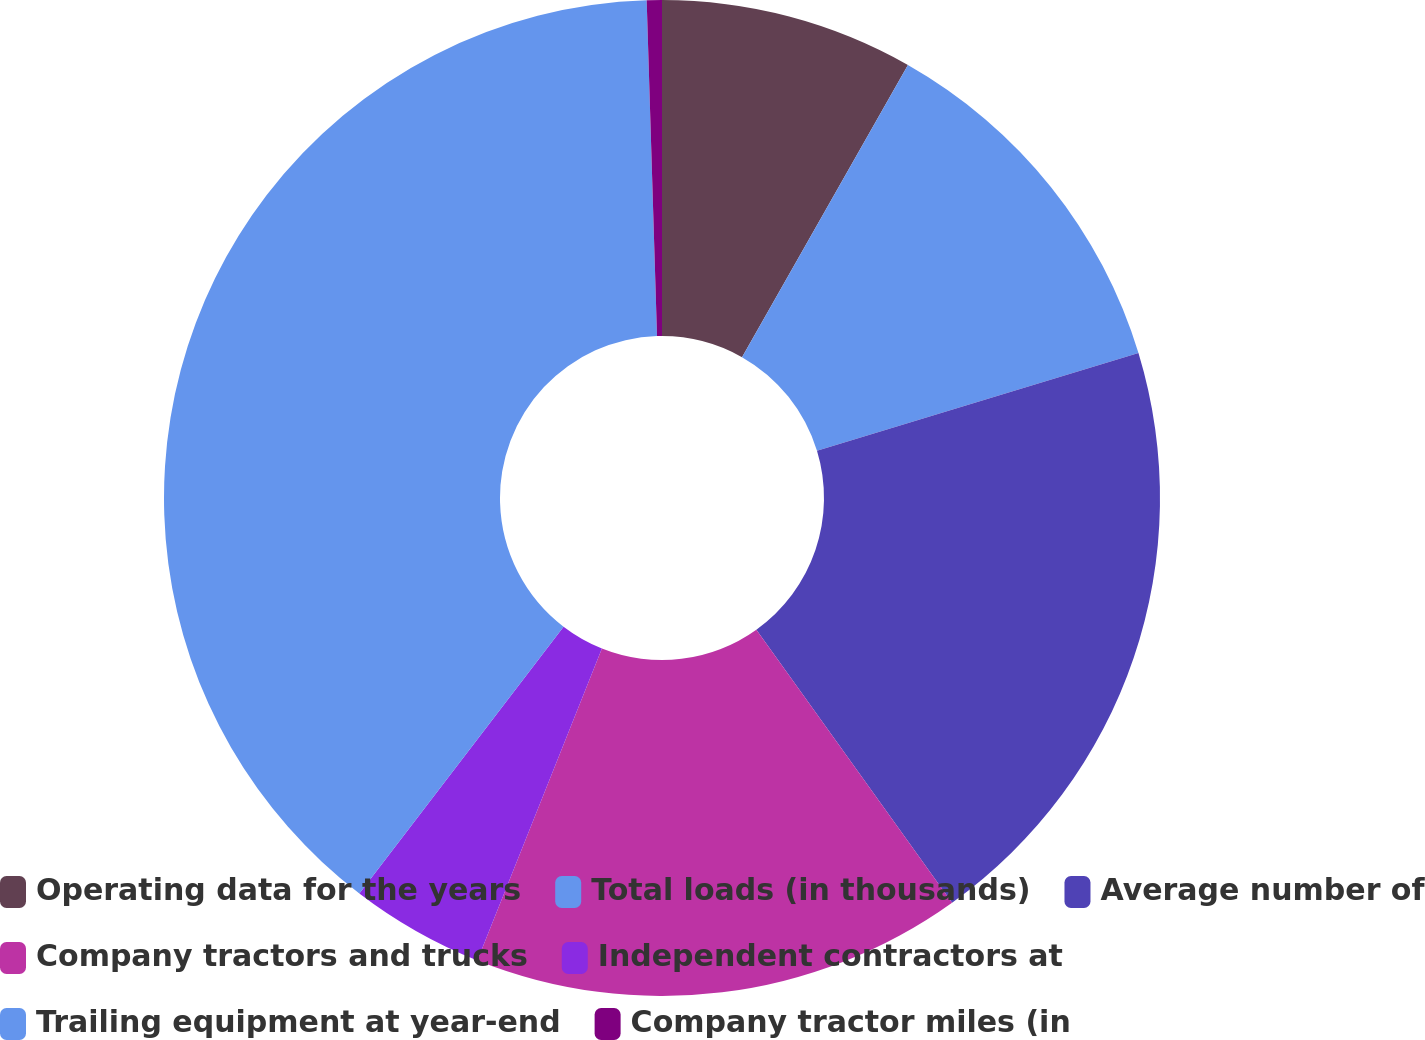Convert chart to OTSL. <chart><loc_0><loc_0><loc_500><loc_500><pie_chart><fcel>Operating data for the years<fcel>Total loads (in thousands)<fcel>Average number of<fcel>Company tractors and trucks<fcel>Independent contractors at<fcel>Trailing equipment at year-end<fcel>Company tractor miles (in<nl><fcel>8.22%<fcel>12.08%<fcel>19.8%<fcel>15.94%<fcel>4.35%<fcel>39.11%<fcel>0.49%<nl></chart> 